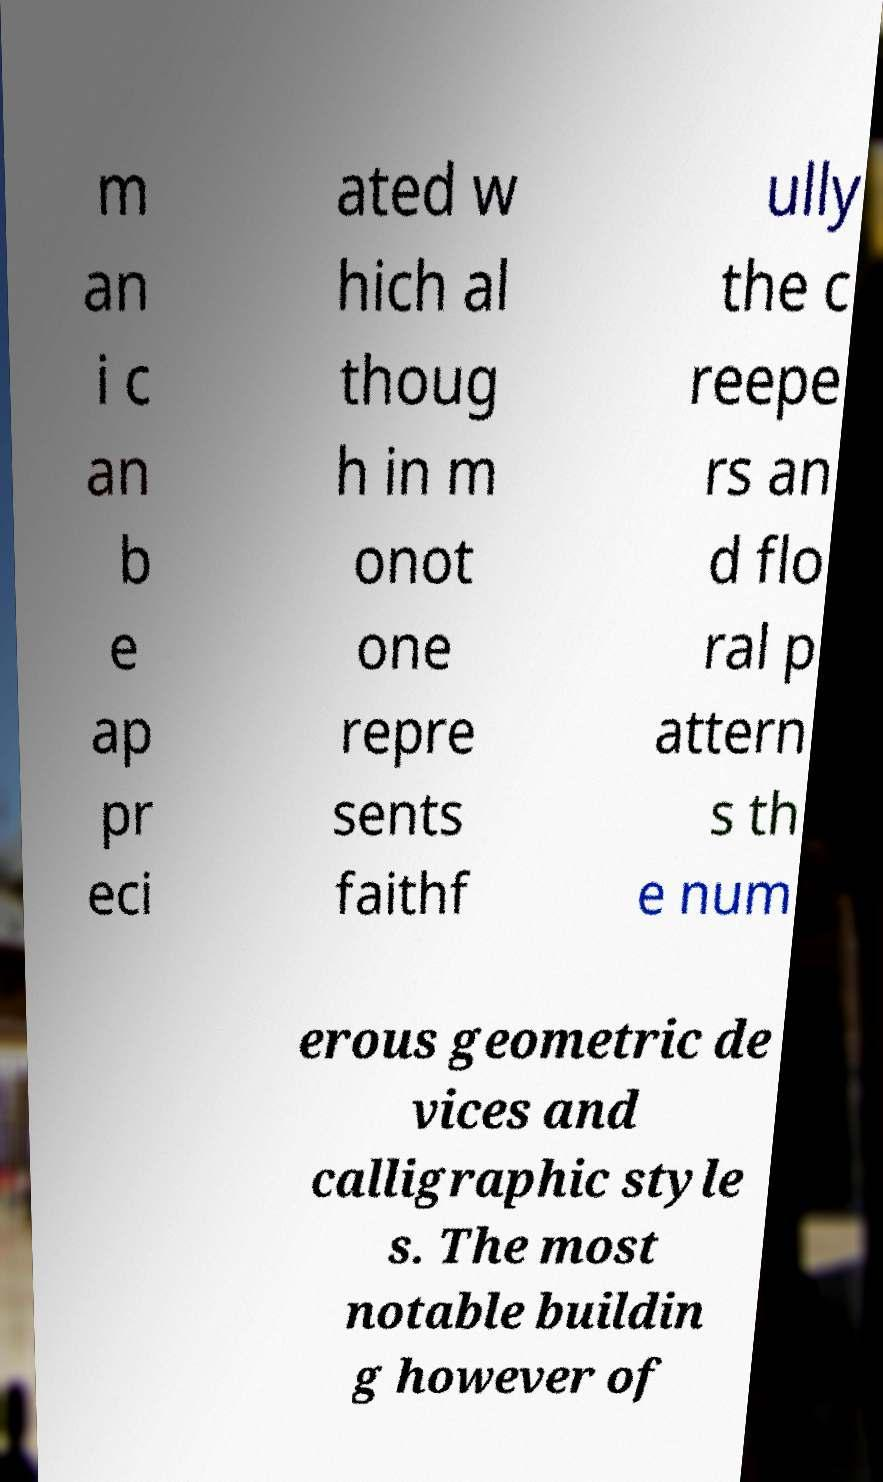I need the written content from this picture converted into text. Can you do that? m an i c an b e ap pr eci ated w hich al thoug h in m onot one repre sents faithf ully the c reepe rs an d flo ral p attern s th e num erous geometric de vices and calligraphic style s. The most notable buildin g however of 